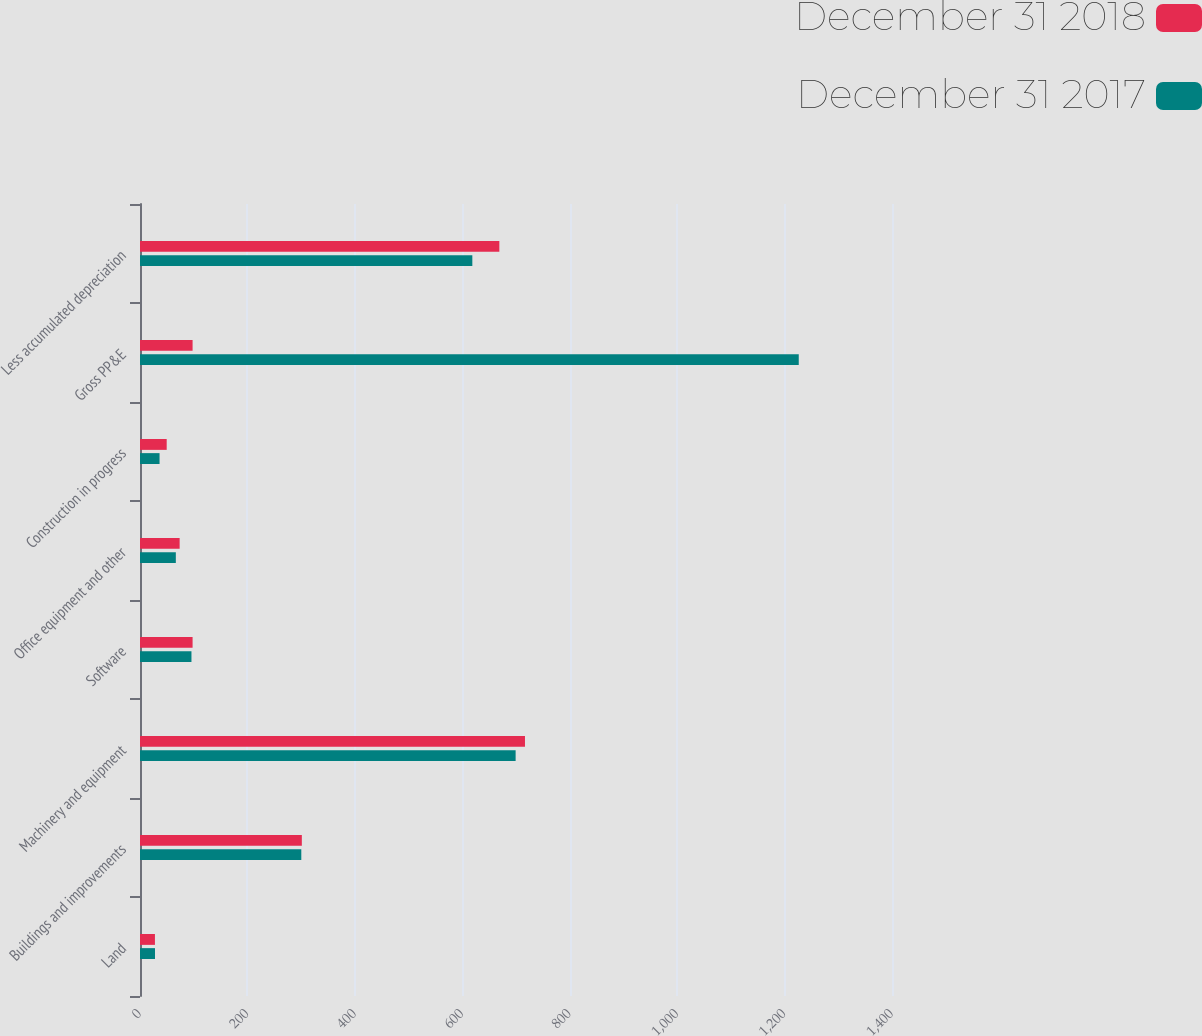Convert chart. <chart><loc_0><loc_0><loc_500><loc_500><stacked_bar_chart><ecel><fcel>Land<fcel>Buildings and improvements<fcel>Machinery and equipment<fcel>Software<fcel>Office equipment and other<fcel>Construction in progress<fcel>Gross PP&E<fcel>Less accumulated depreciation<nl><fcel>December 31 2018<fcel>27.8<fcel>301.3<fcel>716.7<fcel>97.9<fcel>73.8<fcel>49.7<fcel>97.9<fcel>669<nl><fcel>December 31 2017<fcel>27.9<fcel>300.3<fcel>699.3<fcel>95.8<fcel>66.7<fcel>36.4<fcel>1226.4<fcel>618.7<nl></chart> 